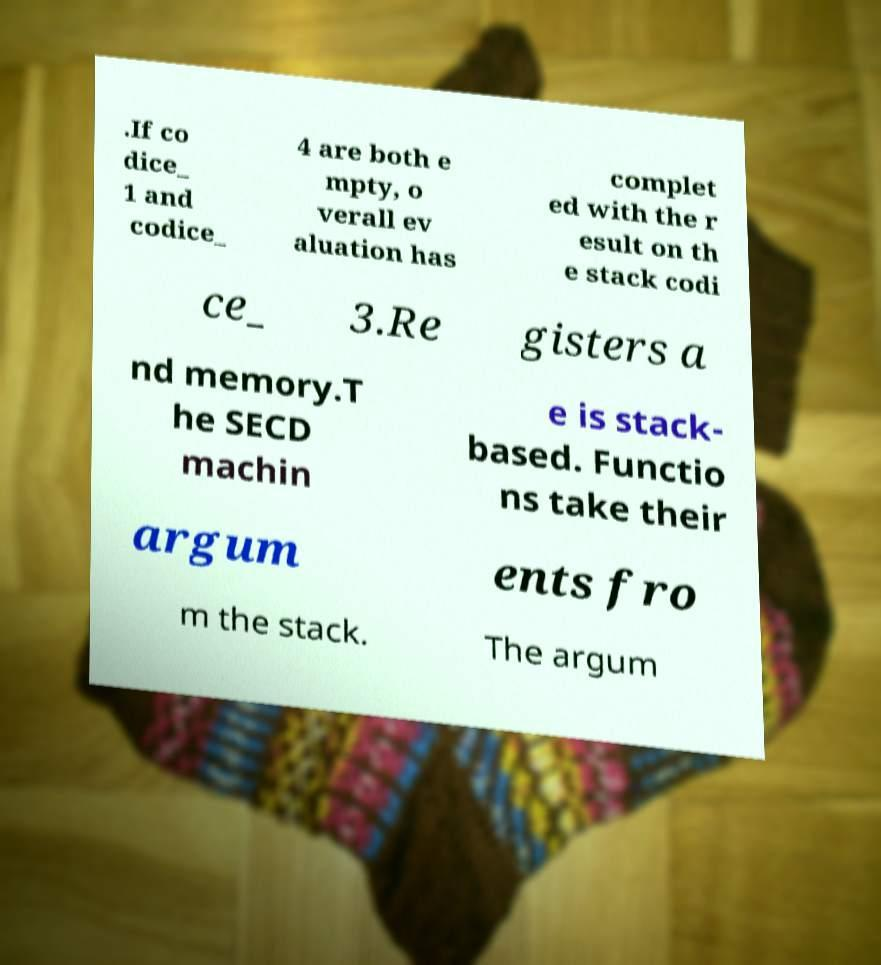Could you assist in decoding the text presented in this image and type it out clearly? .If co dice_ 1 and codice_ 4 are both e mpty, o verall ev aluation has complet ed with the r esult on th e stack codi ce_ 3.Re gisters a nd memory.T he SECD machin e is stack- based. Functio ns take their argum ents fro m the stack. The argum 